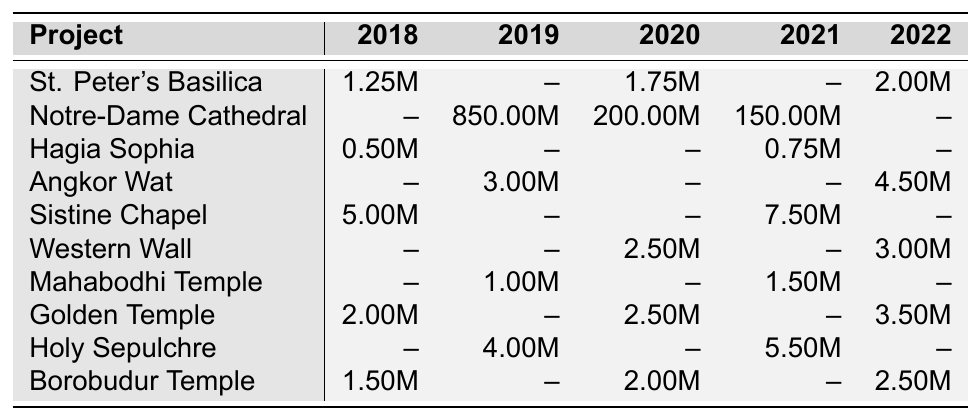What was the highest donation made for the Notre-Dame Cathedral Reconstruction? The table shows that the highest donation for the Notre-Dame Cathedral Reconstruction was in 2019 for 850 million, as it's the only entry and the highest value listed for this project.
Answer: 850 million Which year saw the most donations for the Sistine Chapel Frescoes Restoration? The table shows donations for the Sistine Chapel in 2018 for 5 million and in 2021 for 7.5 million. The highest donation was in 2021.
Answer: 7.5 million Was there a donation made to the Hagia Sophia Conservation in 2019? The table indicates that there are no donations recorded for Hagia Sophia in 2019; thus, the statement is false.
Answer: No How much total donation was recorded for the Golden Temple Preservation from 2018 to 2022? According to the table, the donations for the Golden Temple were 2 million in 2018, 2.5 million in 2020, and 3.5 million in 2022. The total is 2 + 2.5 + 3.5 = 8 million.
Answer: 8 million In which year did the Western Wall Conservation receive its highest donation? The table shows donations for the Western Wall in 2020 for 2.5 million and in 2022 for 3 million. The highest recorded donation was in 2022.
Answer: 2022 What is the average donation for the Church of the Holy Sepulchre Restoration over the years it received donations? The Church of the Holy Sepulchre had donations of 4 million in 2019 and 5.5 million in 2021. The average is (4 + 5.5)/2 = 4.75 million.
Answer: 4.75 million Which restoration project had no donations recorded at all in 2019? Looking through the table, both St. Peter's Basilica and Hagia Sophia had no donations recorded in 2019, confirming that St. Peter's Basilica had also no donations that year.
Answer: St. Peter's Basilica and Hagia Sophia If we compare donations from 2018 to those in 2022 for Borobudur Temple, what is the difference? The donations for Borobudur Temple were 1.5 million in 2018 and 2.5 million in 2022. The difference is 2.5 - 1.5 = 1 million.
Answer: 1 million Which project received the least donation in 2020? The table indicates that in 2020, the Hagia Sophia had no donations, while the lowest recorded donation for other projects was for the Western Wall at 2.5 million. Since Hagia Sophia had no donations, it receives the lowest value.
Answer: Hagia Sophia How many projects received donations in 2021, and what was the total donation amount for that year? In 2021, the projects that received donations were Notre-Dame Cathedral (150 million), Hagia Sophia (750,000), Sistine Chapel (7.5 million), Mahabodhi Temple (1.5 million), Western Wall (3 million), and the Church of the Holy Sepulchre (5.5 million). The total is 150 + 0.75 + 7.5 + 1.5 + 3 + 5.5 = 168.25 million. Thus, 6 projects received donations.
Answer: 6 projects, and total donation is 168.25 million 